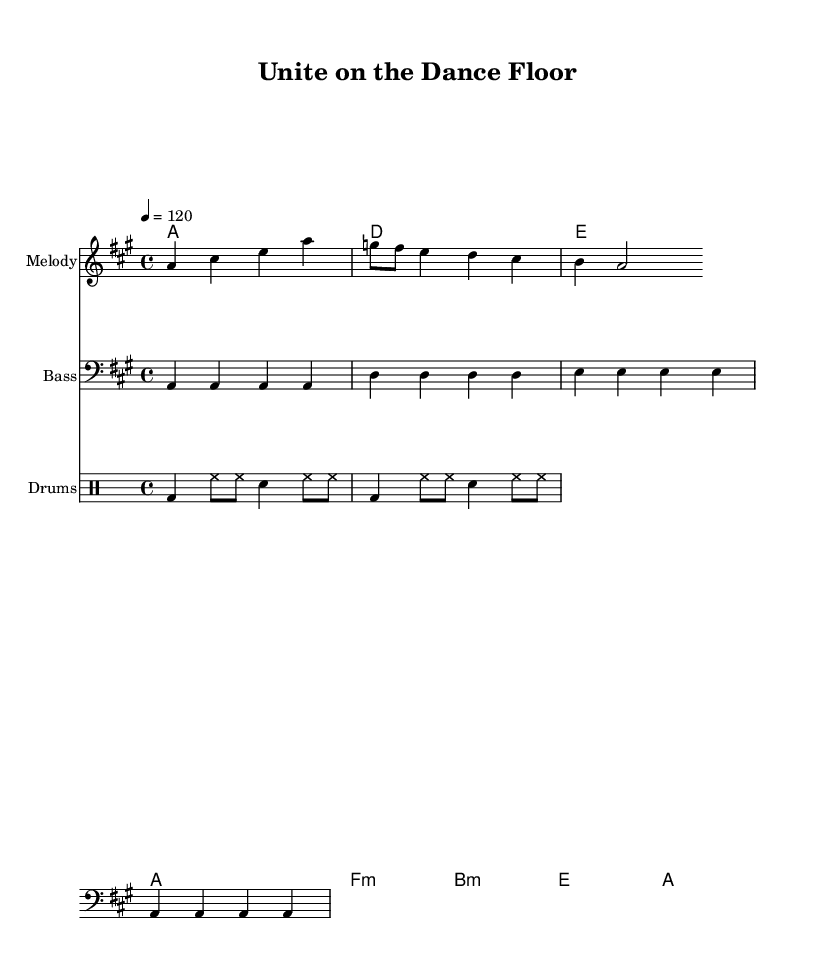What is the key signature of this music? The key signature is A major, which has three sharps (F#, C#, and G#). This is confirmed by the key indication at the beginning of the score.
Answer: A major What is the time signature of this piece? The time signature is 4/4, indicated at the beginning of the score, meaning there are four beats in each measure and the quarter note receives one beat.
Answer: 4/4 What is the tempo marking? The tempo marking is indicated as "4 = 120," which means there should be 120 beats per minute, or two beats for each measure in common terms.
Answer: 120 How many measures are in the melody section? The melody contains a total of 8 measures, which can be counted by observing the structure and phrases in the notation provided in the score.
Answer: 8 What chord type is played in the second measure? The second measure contains a D major chord, evident from the chord symbols indicated above the staff and the notes forming that chord.
Answer: D What is the main lyrical theme of the song? The lyrics suggest themes of unity and togetherness, highlighting the idea of coming together on the dance floor to set things right, indicating a message of bipartisanship.
Answer: Unity In what style is the drum part most commonly played in disco music? The drum part is rhythmically consistent with the characteristic four-on-the-floor beat typical of disco, where the bass drum plays on the downbeats to create a steady groove.
Answer: Four-on-the-floor 